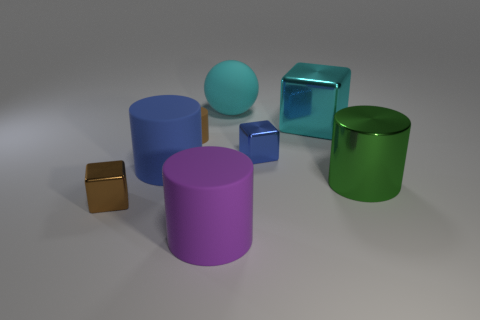How many objects in the image have a circular base? In the provided image, there are four objects with a circular base. This includes two cylinders, one cone, and one sphere. 